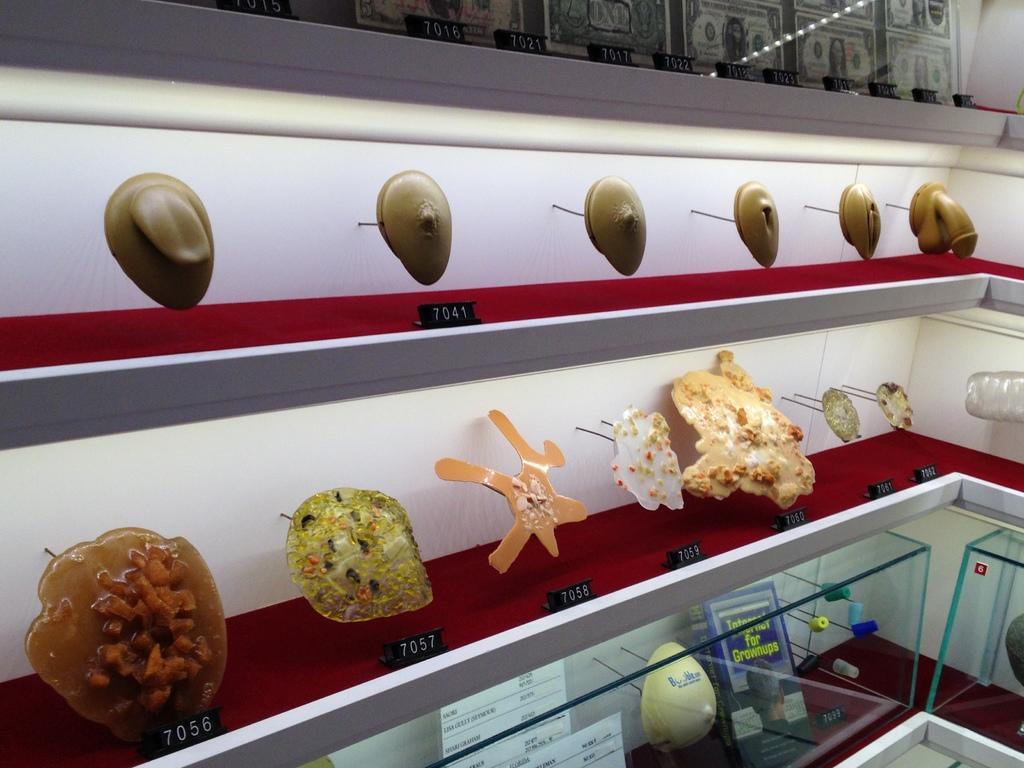In one or two sentences, can you explain what this image depicts? There are some objects arranged on the shelves which are covered with glass. Above them, there is white color wall. 